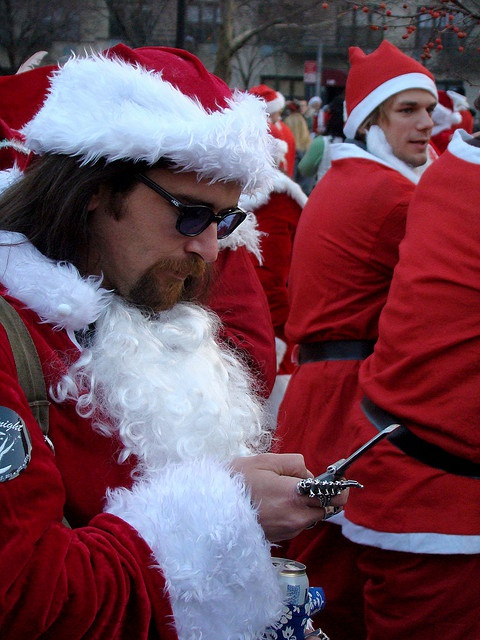Describe the objects in this image and their specific colors. I can see people in black, maroon, lavender, and darkgray tones, people in black, maroon, brown, and darkgray tones, people in black, brown, and maroon tones, people in black, maroon, lavender, and darkgray tones, and cell phone in black, maroon, and gray tones in this image. 